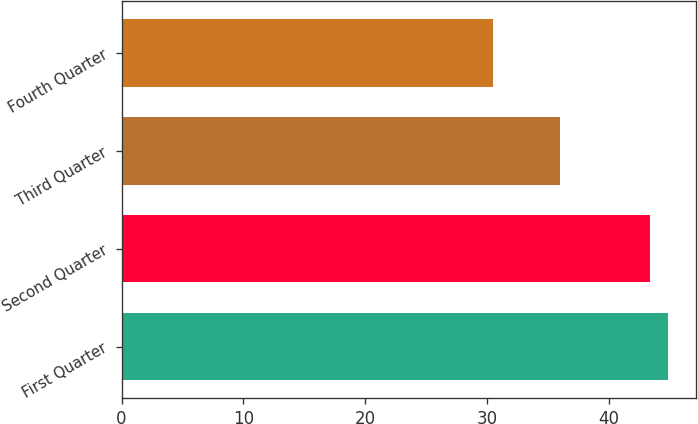<chart> <loc_0><loc_0><loc_500><loc_500><bar_chart><fcel>First Quarter<fcel>Second Quarter<fcel>Third Quarter<fcel>Fourth Quarter<nl><fcel>44.92<fcel>43.4<fcel>36<fcel>30.5<nl></chart> 